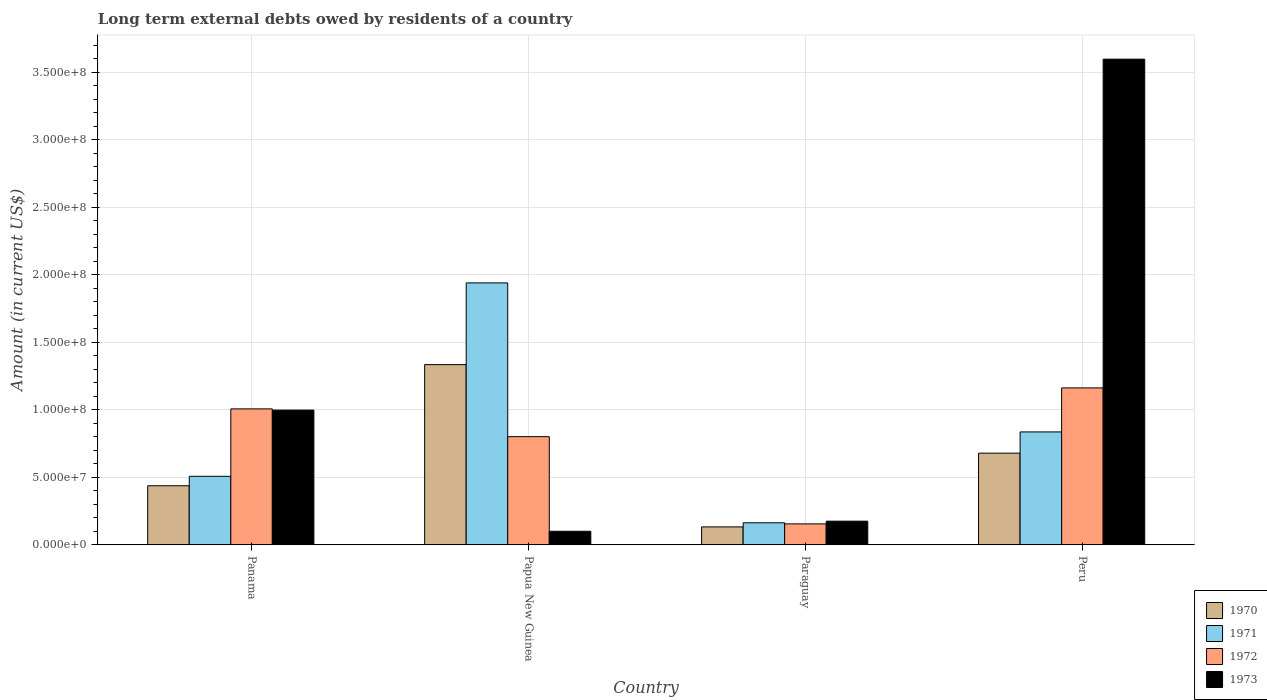Are the number of bars per tick equal to the number of legend labels?
Your response must be concise. Yes. Are the number of bars on each tick of the X-axis equal?
Offer a very short reply. Yes. How many bars are there on the 4th tick from the left?
Provide a short and direct response. 4. How many bars are there on the 3rd tick from the right?
Give a very brief answer. 4. What is the label of the 4th group of bars from the left?
Provide a short and direct response. Peru. In how many cases, is the number of bars for a given country not equal to the number of legend labels?
Provide a succinct answer. 0. What is the amount of long-term external debts owed by residents in 1970 in Papua New Guinea?
Offer a terse response. 1.34e+08. Across all countries, what is the maximum amount of long-term external debts owed by residents in 1970?
Keep it short and to the point. 1.34e+08. Across all countries, what is the minimum amount of long-term external debts owed by residents in 1970?
Keep it short and to the point. 1.34e+07. In which country was the amount of long-term external debts owed by residents in 1971 minimum?
Ensure brevity in your answer.  Paraguay. What is the total amount of long-term external debts owed by residents in 1971 in the graph?
Your answer should be compact. 3.45e+08. What is the difference between the amount of long-term external debts owed by residents in 1972 in Papua New Guinea and that in Paraguay?
Your answer should be compact. 6.46e+07. What is the difference between the amount of long-term external debts owed by residents in 1971 in Panama and the amount of long-term external debts owed by residents in 1970 in Paraguay?
Your answer should be very brief. 3.75e+07. What is the average amount of long-term external debts owed by residents in 1973 per country?
Keep it short and to the point. 1.22e+08. What is the difference between the amount of long-term external debts owed by residents of/in 1973 and amount of long-term external debts owed by residents of/in 1972 in Peru?
Provide a short and direct response. 2.43e+08. In how many countries, is the amount of long-term external debts owed by residents in 1970 greater than 350000000 US$?
Your answer should be very brief. 0. What is the ratio of the amount of long-term external debts owed by residents in 1972 in Papua New Guinea to that in Paraguay?
Provide a short and direct response. 5.14. Is the amount of long-term external debts owed by residents in 1971 in Paraguay less than that in Peru?
Provide a succinct answer. Yes. What is the difference between the highest and the second highest amount of long-term external debts owed by residents in 1972?
Give a very brief answer. 3.61e+07. What is the difference between the highest and the lowest amount of long-term external debts owed by residents in 1970?
Offer a terse response. 1.20e+08. In how many countries, is the amount of long-term external debts owed by residents in 1973 greater than the average amount of long-term external debts owed by residents in 1973 taken over all countries?
Provide a succinct answer. 1. How many bars are there?
Provide a succinct answer. 16. How many countries are there in the graph?
Your response must be concise. 4. Does the graph contain any zero values?
Provide a succinct answer. No. Does the graph contain grids?
Make the answer very short. Yes. Where does the legend appear in the graph?
Offer a terse response. Bottom right. How many legend labels are there?
Your answer should be very brief. 4. What is the title of the graph?
Make the answer very short. Long term external debts owed by residents of a country. What is the label or title of the X-axis?
Provide a short and direct response. Country. What is the Amount (in current US$) in 1970 in Panama?
Your answer should be very brief. 4.38e+07. What is the Amount (in current US$) in 1971 in Panama?
Give a very brief answer. 5.08e+07. What is the Amount (in current US$) of 1972 in Panama?
Provide a short and direct response. 1.01e+08. What is the Amount (in current US$) in 1973 in Panama?
Your answer should be compact. 9.99e+07. What is the Amount (in current US$) in 1970 in Papua New Guinea?
Your answer should be compact. 1.34e+08. What is the Amount (in current US$) of 1971 in Papua New Guinea?
Offer a very short reply. 1.94e+08. What is the Amount (in current US$) of 1972 in Papua New Guinea?
Keep it short and to the point. 8.02e+07. What is the Amount (in current US$) in 1973 in Papua New Guinea?
Keep it short and to the point. 1.01e+07. What is the Amount (in current US$) in 1970 in Paraguay?
Your response must be concise. 1.34e+07. What is the Amount (in current US$) of 1971 in Paraguay?
Ensure brevity in your answer.  1.64e+07. What is the Amount (in current US$) of 1972 in Paraguay?
Make the answer very short. 1.56e+07. What is the Amount (in current US$) in 1973 in Paraguay?
Offer a terse response. 1.76e+07. What is the Amount (in current US$) of 1970 in Peru?
Ensure brevity in your answer.  6.80e+07. What is the Amount (in current US$) of 1971 in Peru?
Ensure brevity in your answer.  8.37e+07. What is the Amount (in current US$) of 1972 in Peru?
Offer a terse response. 1.16e+08. What is the Amount (in current US$) in 1973 in Peru?
Make the answer very short. 3.60e+08. Across all countries, what is the maximum Amount (in current US$) of 1970?
Your response must be concise. 1.34e+08. Across all countries, what is the maximum Amount (in current US$) in 1971?
Your answer should be very brief. 1.94e+08. Across all countries, what is the maximum Amount (in current US$) of 1972?
Your answer should be compact. 1.16e+08. Across all countries, what is the maximum Amount (in current US$) of 1973?
Provide a succinct answer. 3.60e+08. Across all countries, what is the minimum Amount (in current US$) of 1970?
Provide a succinct answer. 1.34e+07. Across all countries, what is the minimum Amount (in current US$) of 1971?
Provide a succinct answer. 1.64e+07. Across all countries, what is the minimum Amount (in current US$) of 1972?
Offer a terse response. 1.56e+07. Across all countries, what is the minimum Amount (in current US$) in 1973?
Make the answer very short. 1.01e+07. What is the total Amount (in current US$) in 1970 in the graph?
Your answer should be very brief. 2.59e+08. What is the total Amount (in current US$) in 1971 in the graph?
Your answer should be compact. 3.45e+08. What is the total Amount (in current US$) in 1972 in the graph?
Ensure brevity in your answer.  3.13e+08. What is the total Amount (in current US$) of 1973 in the graph?
Give a very brief answer. 4.87e+08. What is the difference between the Amount (in current US$) in 1970 in Panama and that in Papua New Guinea?
Your answer should be very brief. -8.97e+07. What is the difference between the Amount (in current US$) of 1971 in Panama and that in Papua New Guinea?
Provide a succinct answer. -1.43e+08. What is the difference between the Amount (in current US$) of 1972 in Panama and that in Papua New Guinea?
Your answer should be very brief. 2.06e+07. What is the difference between the Amount (in current US$) of 1973 in Panama and that in Papua New Guinea?
Your response must be concise. 8.97e+07. What is the difference between the Amount (in current US$) of 1970 in Panama and that in Paraguay?
Your response must be concise. 3.05e+07. What is the difference between the Amount (in current US$) in 1971 in Panama and that in Paraguay?
Your answer should be compact. 3.44e+07. What is the difference between the Amount (in current US$) in 1972 in Panama and that in Paraguay?
Your answer should be compact. 8.52e+07. What is the difference between the Amount (in current US$) of 1973 in Panama and that in Paraguay?
Offer a very short reply. 8.23e+07. What is the difference between the Amount (in current US$) in 1970 in Panama and that in Peru?
Ensure brevity in your answer.  -2.41e+07. What is the difference between the Amount (in current US$) of 1971 in Panama and that in Peru?
Your answer should be very brief. -3.29e+07. What is the difference between the Amount (in current US$) in 1972 in Panama and that in Peru?
Give a very brief answer. -1.56e+07. What is the difference between the Amount (in current US$) in 1973 in Panama and that in Peru?
Your answer should be compact. -2.60e+08. What is the difference between the Amount (in current US$) in 1970 in Papua New Guinea and that in Paraguay?
Keep it short and to the point. 1.20e+08. What is the difference between the Amount (in current US$) in 1971 in Papua New Guinea and that in Paraguay?
Give a very brief answer. 1.78e+08. What is the difference between the Amount (in current US$) in 1972 in Papua New Guinea and that in Paraguay?
Provide a succinct answer. 6.46e+07. What is the difference between the Amount (in current US$) of 1973 in Papua New Guinea and that in Paraguay?
Provide a short and direct response. -7.47e+06. What is the difference between the Amount (in current US$) in 1970 in Papua New Guinea and that in Peru?
Your answer should be compact. 6.56e+07. What is the difference between the Amount (in current US$) of 1971 in Papua New Guinea and that in Peru?
Make the answer very short. 1.10e+08. What is the difference between the Amount (in current US$) of 1972 in Papua New Guinea and that in Peru?
Give a very brief answer. -3.61e+07. What is the difference between the Amount (in current US$) in 1973 in Papua New Guinea and that in Peru?
Make the answer very short. -3.50e+08. What is the difference between the Amount (in current US$) in 1970 in Paraguay and that in Peru?
Keep it short and to the point. -5.46e+07. What is the difference between the Amount (in current US$) of 1971 in Paraguay and that in Peru?
Give a very brief answer. -6.73e+07. What is the difference between the Amount (in current US$) of 1972 in Paraguay and that in Peru?
Keep it short and to the point. -1.01e+08. What is the difference between the Amount (in current US$) in 1973 in Paraguay and that in Peru?
Ensure brevity in your answer.  -3.42e+08. What is the difference between the Amount (in current US$) in 1970 in Panama and the Amount (in current US$) in 1971 in Papua New Guinea?
Make the answer very short. -1.50e+08. What is the difference between the Amount (in current US$) in 1970 in Panama and the Amount (in current US$) in 1972 in Papua New Guinea?
Give a very brief answer. -3.64e+07. What is the difference between the Amount (in current US$) in 1970 in Panama and the Amount (in current US$) in 1973 in Papua New Guinea?
Offer a terse response. 3.37e+07. What is the difference between the Amount (in current US$) in 1971 in Panama and the Amount (in current US$) in 1972 in Papua New Guinea?
Ensure brevity in your answer.  -2.94e+07. What is the difference between the Amount (in current US$) in 1971 in Panama and the Amount (in current US$) in 1973 in Papua New Guinea?
Offer a terse response. 4.07e+07. What is the difference between the Amount (in current US$) of 1972 in Panama and the Amount (in current US$) of 1973 in Papua New Guinea?
Ensure brevity in your answer.  9.06e+07. What is the difference between the Amount (in current US$) of 1970 in Panama and the Amount (in current US$) of 1971 in Paraguay?
Offer a very short reply. 2.74e+07. What is the difference between the Amount (in current US$) of 1970 in Panama and the Amount (in current US$) of 1972 in Paraguay?
Your answer should be compact. 2.82e+07. What is the difference between the Amount (in current US$) in 1970 in Panama and the Amount (in current US$) in 1973 in Paraguay?
Your answer should be compact. 2.62e+07. What is the difference between the Amount (in current US$) of 1971 in Panama and the Amount (in current US$) of 1972 in Paraguay?
Provide a short and direct response. 3.52e+07. What is the difference between the Amount (in current US$) of 1971 in Panama and the Amount (in current US$) of 1973 in Paraguay?
Your response must be concise. 3.32e+07. What is the difference between the Amount (in current US$) of 1972 in Panama and the Amount (in current US$) of 1973 in Paraguay?
Ensure brevity in your answer.  8.32e+07. What is the difference between the Amount (in current US$) in 1970 in Panama and the Amount (in current US$) in 1971 in Peru?
Keep it short and to the point. -3.99e+07. What is the difference between the Amount (in current US$) of 1970 in Panama and the Amount (in current US$) of 1972 in Peru?
Your response must be concise. -7.25e+07. What is the difference between the Amount (in current US$) of 1970 in Panama and the Amount (in current US$) of 1973 in Peru?
Your answer should be compact. -3.16e+08. What is the difference between the Amount (in current US$) of 1971 in Panama and the Amount (in current US$) of 1972 in Peru?
Provide a succinct answer. -6.55e+07. What is the difference between the Amount (in current US$) in 1971 in Panama and the Amount (in current US$) in 1973 in Peru?
Your answer should be very brief. -3.09e+08. What is the difference between the Amount (in current US$) of 1972 in Panama and the Amount (in current US$) of 1973 in Peru?
Offer a terse response. -2.59e+08. What is the difference between the Amount (in current US$) in 1970 in Papua New Guinea and the Amount (in current US$) in 1971 in Paraguay?
Provide a succinct answer. 1.17e+08. What is the difference between the Amount (in current US$) in 1970 in Papua New Guinea and the Amount (in current US$) in 1972 in Paraguay?
Give a very brief answer. 1.18e+08. What is the difference between the Amount (in current US$) in 1970 in Papua New Guinea and the Amount (in current US$) in 1973 in Paraguay?
Your answer should be compact. 1.16e+08. What is the difference between the Amount (in current US$) in 1971 in Papua New Guinea and the Amount (in current US$) in 1972 in Paraguay?
Give a very brief answer. 1.78e+08. What is the difference between the Amount (in current US$) in 1971 in Papua New Guinea and the Amount (in current US$) in 1973 in Paraguay?
Make the answer very short. 1.77e+08. What is the difference between the Amount (in current US$) in 1972 in Papua New Guinea and the Amount (in current US$) in 1973 in Paraguay?
Your answer should be compact. 6.26e+07. What is the difference between the Amount (in current US$) in 1970 in Papua New Guinea and the Amount (in current US$) in 1971 in Peru?
Provide a short and direct response. 4.98e+07. What is the difference between the Amount (in current US$) of 1970 in Papua New Guinea and the Amount (in current US$) of 1972 in Peru?
Provide a succinct answer. 1.72e+07. What is the difference between the Amount (in current US$) of 1970 in Papua New Guinea and the Amount (in current US$) of 1973 in Peru?
Offer a terse response. -2.26e+08. What is the difference between the Amount (in current US$) of 1971 in Papua New Guinea and the Amount (in current US$) of 1972 in Peru?
Offer a very short reply. 7.78e+07. What is the difference between the Amount (in current US$) of 1971 in Papua New Guinea and the Amount (in current US$) of 1973 in Peru?
Your answer should be very brief. -1.66e+08. What is the difference between the Amount (in current US$) of 1972 in Papua New Guinea and the Amount (in current US$) of 1973 in Peru?
Provide a short and direct response. -2.80e+08. What is the difference between the Amount (in current US$) in 1970 in Paraguay and the Amount (in current US$) in 1971 in Peru?
Offer a terse response. -7.03e+07. What is the difference between the Amount (in current US$) of 1970 in Paraguay and the Amount (in current US$) of 1972 in Peru?
Make the answer very short. -1.03e+08. What is the difference between the Amount (in current US$) in 1970 in Paraguay and the Amount (in current US$) in 1973 in Peru?
Provide a short and direct response. -3.46e+08. What is the difference between the Amount (in current US$) of 1971 in Paraguay and the Amount (in current US$) of 1972 in Peru?
Provide a short and direct response. -9.99e+07. What is the difference between the Amount (in current US$) of 1971 in Paraguay and the Amount (in current US$) of 1973 in Peru?
Your answer should be very brief. -3.43e+08. What is the difference between the Amount (in current US$) of 1972 in Paraguay and the Amount (in current US$) of 1973 in Peru?
Give a very brief answer. -3.44e+08. What is the average Amount (in current US$) of 1970 per country?
Offer a terse response. 6.47e+07. What is the average Amount (in current US$) of 1971 per country?
Offer a very short reply. 8.63e+07. What is the average Amount (in current US$) in 1972 per country?
Provide a short and direct response. 7.82e+07. What is the average Amount (in current US$) in 1973 per country?
Your answer should be compact. 1.22e+08. What is the difference between the Amount (in current US$) of 1970 and Amount (in current US$) of 1971 in Panama?
Offer a very short reply. -6.98e+06. What is the difference between the Amount (in current US$) of 1970 and Amount (in current US$) of 1972 in Panama?
Your answer should be very brief. -5.69e+07. What is the difference between the Amount (in current US$) in 1970 and Amount (in current US$) in 1973 in Panama?
Your answer should be compact. -5.60e+07. What is the difference between the Amount (in current US$) in 1971 and Amount (in current US$) in 1972 in Panama?
Provide a succinct answer. -5.00e+07. What is the difference between the Amount (in current US$) of 1971 and Amount (in current US$) of 1973 in Panama?
Offer a very short reply. -4.90e+07. What is the difference between the Amount (in current US$) of 1972 and Amount (in current US$) of 1973 in Panama?
Offer a terse response. 9.03e+05. What is the difference between the Amount (in current US$) in 1970 and Amount (in current US$) in 1971 in Papua New Guinea?
Give a very brief answer. -6.05e+07. What is the difference between the Amount (in current US$) in 1970 and Amount (in current US$) in 1972 in Papua New Guinea?
Offer a very short reply. 5.34e+07. What is the difference between the Amount (in current US$) of 1970 and Amount (in current US$) of 1973 in Papua New Guinea?
Provide a succinct answer. 1.23e+08. What is the difference between the Amount (in current US$) of 1971 and Amount (in current US$) of 1972 in Papua New Guinea?
Provide a succinct answer. 1.14e+08. What is the difference between the Amount (in current US$) of 1971 and Amount (in current US$) of 1973 in Papua New Guinea?
Keep it short and to the point. 1.84e+08. What is the difference between the Amount (in current US$) of 1972 and Amount (in current US$) of 1973 in Papua New Guinea?
Your answer should be compact. 7.01e+07. What is the difference between the Amount (in current US$) of 1970 and Amount (in current US$) of 1971 in Paraguay?
Offer a very short reply. -3.05e+06. What is the difference between the Amount (in current US$) in 1970 and Amount (in current US$) in 1972 in Paraguay?
Your answer should be compact. -2.23e+06. What is the difference between the Amount (in current US$) in 1970 and Amount (in current US$) in 1973 in Paraguay?
Your answer should be very brief. -4.23e+06. What is the difference between the Amount (in current US$) of 1971 and Amount (in current US$) of 1972 in Paraguay?
Your answer should be very brief. 8.15e+05. What is the difference between the Amount (in current US$) in 1971 and Amount (in current US$) in 1973 in Paraguay?
Provide a short and direct response. -1.18e+06. What is the difference between the Amount (in current US$) in 1972 and Amount (in current US$) in 1973 in Paraguay?
Give a very brief answer. -2.00e+06. What is the difference between the Amount (in current US$) of 1970 and Amount (in current US$) of 1971 in Peru?
Keep it short and to the point. -1.57e+07. What is the difference between the Amount (in current US$) of 1970 and Amount (in current US$) of 1972 in Peru?
Offer a terse response. -4.83e+07. What is the difference between the Amount (in current US$) of 1970 and Amount (in current US$) of 1973 in Peru?
Provide a short and direct response. -2.92e+08. What is the difference between the Amount (in current US$) in 1971 and Amount (in current US$) in 1972 in Peru?
Give a very brief answer. -3.26e+07. What is the difference between the Amount (in current US$) in 1971 and Amount (in current US$) in 1973 in Peru?
Offer a very short reply. -2.76e+08. What is the difference between the Amount (in current US$) in 1972 and Amount (in current US$) in 1973 in Peru?
Ensure brevity in your answer.  -2.43e+08. What is the ratio of the Amount (in current US$) of 1970 in Panama to that in Papua New Guinea?
Offer a very short reply. 0.33. What is the ratio of the Amount (in current US$) in 1971 in Panama to that in Papua New Guinea?
Provide a succinct answer. 0.26. What is the ratio of the Amount (in current US$) in 1972 in Panama to that in Papua New Guinea?
Offer a very short reply. 1.26. What is the ratio of the Amount (in current US$) of 1973 in Panama to that in Papua New Guinea?
Offer a terse response. 9.87. What is the ratio of the Amount (in current US$) of 1970 in Panama to that in Paraguay?
Make the answer very short. 3.28. What is the ratio of the Amount (in current US$) of 1971 in Panama to that in Paraguay?
Ensure brevity in your answer.  3.1. What is the ratio of the Amount (in current US$) in 1972 in Panama to that in Paraguay?
Keep it short and to the point. 6.46. What is the ratio of the Amount (in current US$) of 1973 in Panama to that in Paraguay?
Keep it short and to the point. 5.68. What is the ratio of the Amount (in current US$) of 1970 in Panama to that in Peru?
Give a very brief answer. 0.64. What is the ratio of the Amount (in current US$) of 1971 in Panama to that in Peru?
Offer a terse response. 0.61. What is the ratio of the Amount (in current US$) of 1972 in Panama to that in Peru?
Ensure brevity in your answer.  0.87. What is the ratio of the Amount (in current US$) of 1973 in Panama to that in Peru?
Give a very brief answer. 0.28. What is the ratio of the Amount (in current US$) of 1970 in Papua New Guinea to that in Paraguay?
Provide a succinct answer. 10. What is the ratio of the Amount (in current US$) in 1971 in Papua New Guinea to that in Paraguay?
Provide a short and direct response. 11.83. What is the ratio of the Amount (in current US$) in 1972 in Papua New Guinea to that in Paraguay?
Offer a very short reply. 5.14. What is the ratio of the Amount (in current US$) of 1973 in Papua New Guinea to that in Paraguay?
Your answer should be very brief. 0.58. What is the ratio of the Amount (in current US$) of 1970 in Papua New Guinea to that in Peru?
Make the answer very short. 1.96. What is the ratio of the Amount (in current US$) of 1971 in Papua New Guinea to that in Peru?
Your response must be concise. 2.32. What is the ratio of the Amount (in current US$) of 1972 in Papua New Guinea to that in Peru?
Offer a very short reply. 0.69. What is the ratio of the Amount (in current US$) of 1973 in Papua New Guinea to that in Peru?
Provide a succinct answer. 0.03. What is the ratio of the Amount (in current US$) of 1970 in Paraguay to that in Peru?
Your response must be concise. 0.2. What is the ratio of the Amount (in current US$) in 1971 in Paraguay to that in Peru?
Offer a terse response. 0.2. What is the ratio of the Amount (in current US$) of 1972 in Paraguay to that in Peru?
Your response must be concise. 0.13. What is the ratio of the Amount (in current US$) in 1973 in Paraguay to that in Peru?
Your answer should be very brief. 0.05. What is the difference between the highest and the second highest Amount (in current US$) in 1970?
Offer a terse response. 6.56e+07. What is the difference between the highest and the second highest Amount (in current US$) of 1971?
Your answer should be compact. 1.10e+08. What is the difference between the highest and the second highest Amount (in current US$) in 1972?
Offer a very short reply. 1.56e+07. What is the difference between the highest and the second highest Amount (in current US$) of 1973?
Keep it short and to the point. 2.60e+08. What is the difference between the highest and the lowest Amount (in current US$) in 1970?
Your answer should be very brief. 1.20e+08. What is the difference between the highest and the lowest Amount (in current US$) in 1971?
Provide a succinct answer. 1.78e+08. What is the difference between the highest and the lowest Amount (in current US$) in 1972?
Offer a terse response. 1.01e+08. What is the difference between the highest and the lowest Amount (in current US$) of 1973?
Your answer should be very brief. 3.50e+08. 